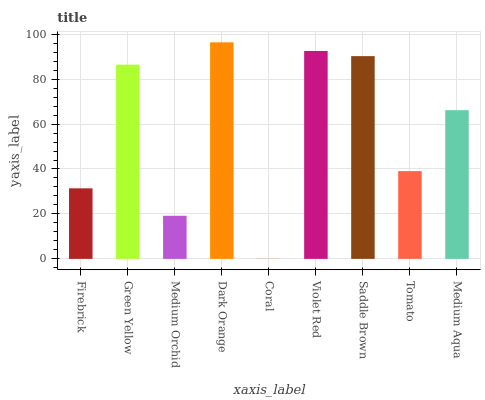Is Coral the minimum?
Answer yes or no. Yes. Is Dark Orange the maximum?
Answer yes or no. Yes. Is Green Yellow the minimum?
Answer yes or no. No. Is Green Yellow the maximum?
Answer yes or no. No. Is Green Yellow greater than Firebrick?
Answer yes or no. Yes. Is Firebrick less than Green Yellow?
Answer yes or no. Yes. Is Firebrick greater than Green Yellow?
Answer yes or no. No. Is Green Yellow less than Firebrick?
Answer yes or no. No. Is Medium Aqua the high median?
Answer yes or no. Yes. Is Medium Aqua the low median?
Answer yes or no. Yes. Is Dark Orange the high median?
Answer yes or no. No. Is Saddle Brown the low median?
Answer yes or no. No. 